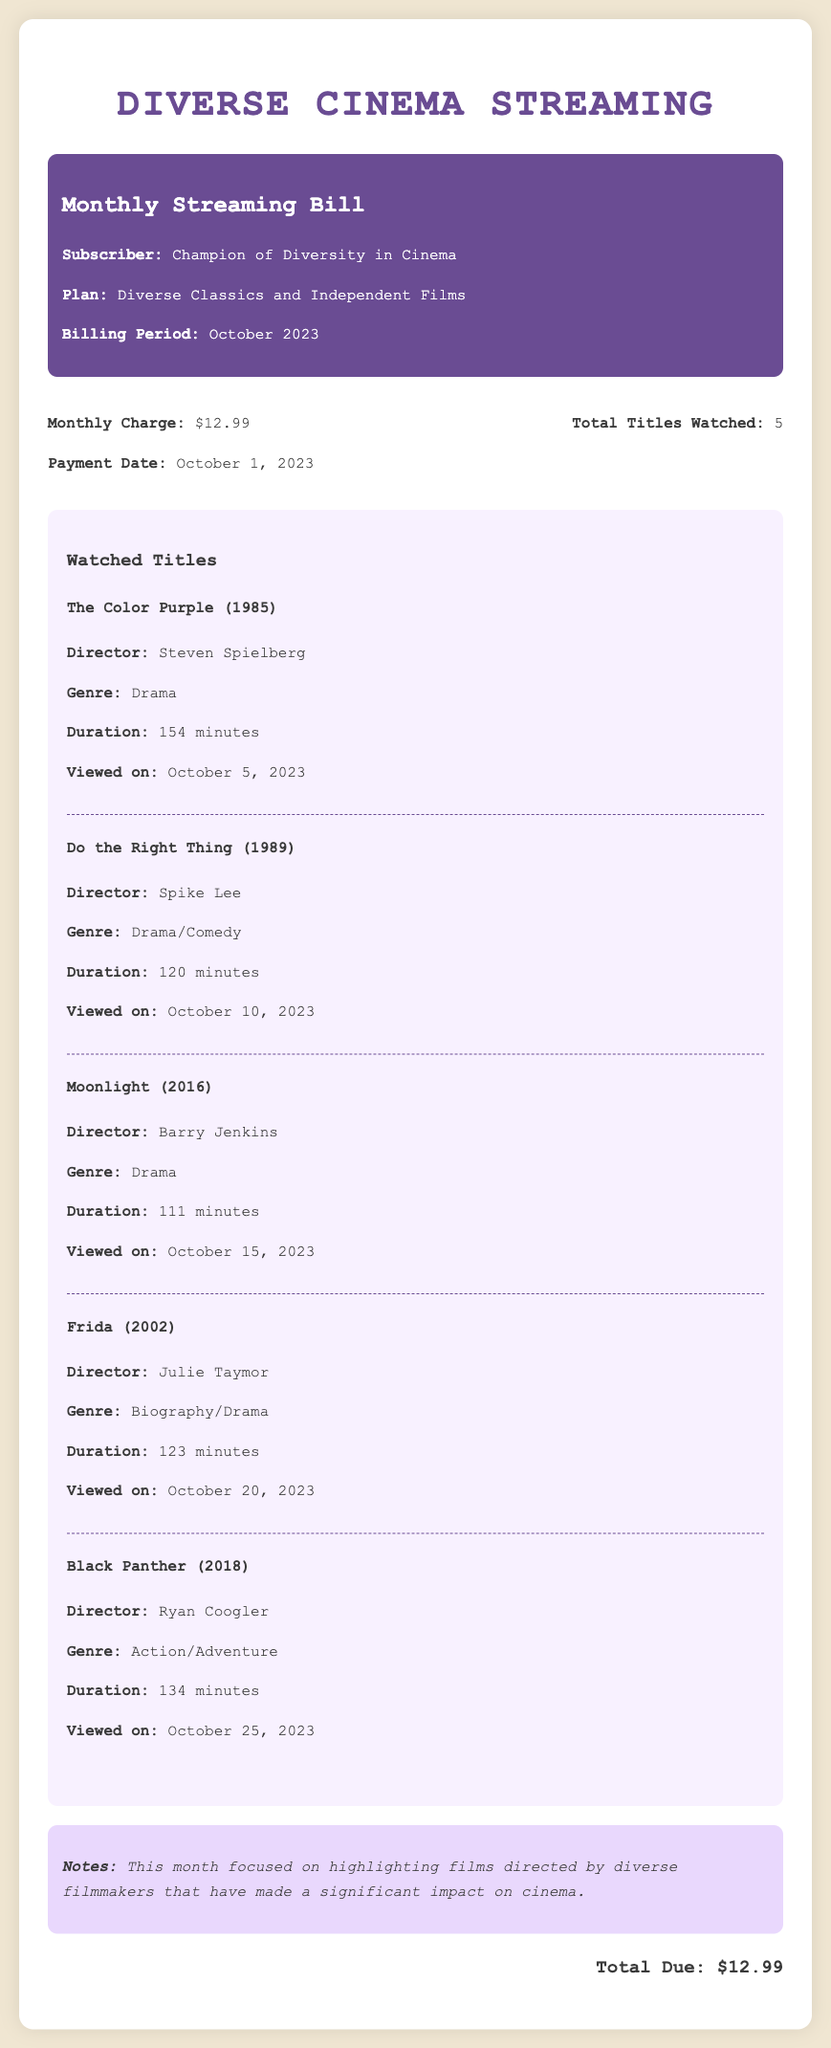what is the monthly charge? The monthly charge for the subscription plan is stated in the document as $12.99.
Answer: $12.99 who is the subscriber? The subscriber's name is provided in the bill as "Champion of Diversity in Cinema."
Answer: Champion of Diversity in Cinema how many titles were watched? The document indicates the total number of titles watched during the billing period is 5.
Answer: 5 what is the genre of "Do the Right Thing"? In the document, the genre of "Do the Right Thing" is classified as Drama/Comedy.
Answer: Drama/Comedy what is the duration of "Moonlight"? The duration of "Moonlight" is specified in the document as 111 minutes.
Answer: 111 minutes who directed "Frida"? The document lists "Julie Taymor" as the director of "Frida."
Answer: Julie Taymor on what date was the payment made? The payment date is noted in the document as October 1, 2023.
Answer: October 1, 2023 what type of films does the subscription plan include? The document describes the plan to include "Diverse Classics and Independent Films."
Answer: Diverse Classics and Independent Films what was the focus of this month’s films? The document states that the focus was on films directed by diverse filmmakers that have made a significant impact on cinema.
Answer: Highlighting films directed by diverse filmmakers 